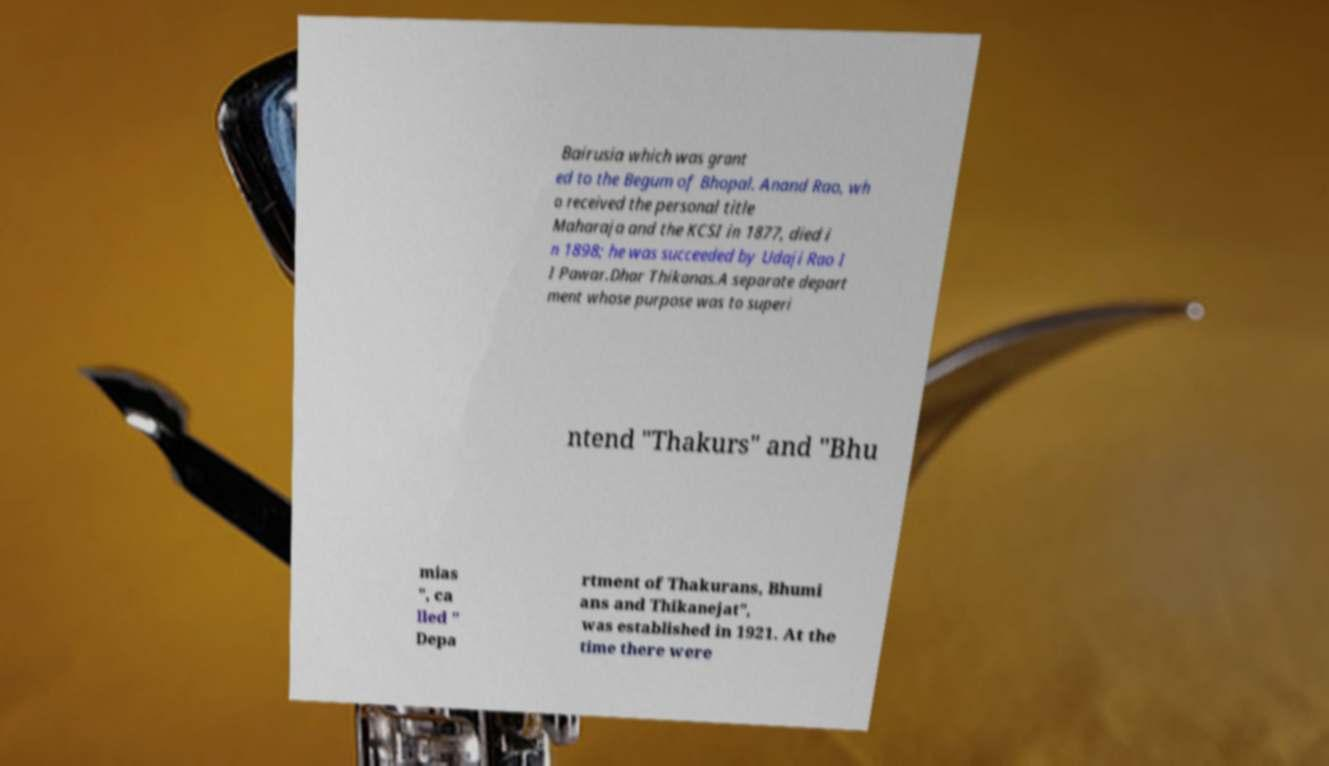Can you accurately transcribe the text from the provided image for me? Bairusia which was grant ed to the Begum of Bhopal. Anand Rao, wh o received the personal title Maharaja and the KCSI in 1877, died i n 1898; he was succeeded by Udaji Rao I I Pawar.Dhar Thikanas.A separate depart ment whose purpose was to superi ntend "Thakurs" and "Bhu mias ", ca lled " Depa rtment of Thakurans, Bhumi ans and Thikanejat", was established in 1921. At the time there were 